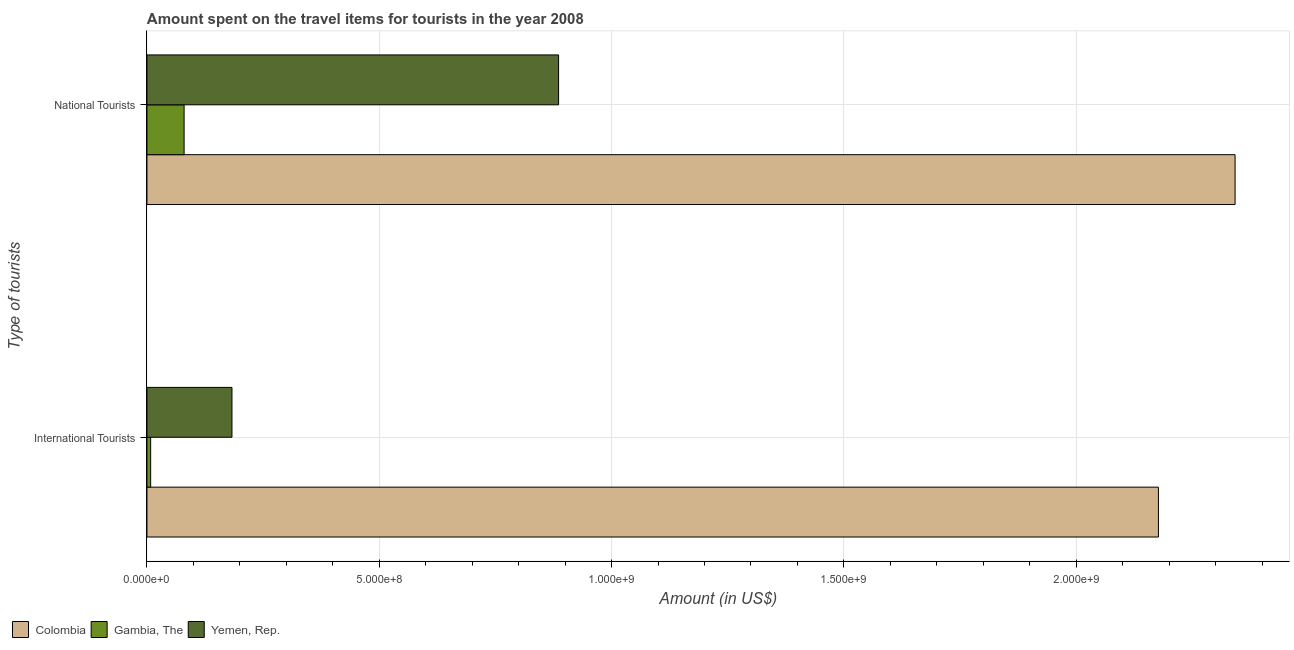How many different coloured bars are there?
Your answer should be very brief. 3. How many groups of bars are there?
Provide a succinct answer. 2. Are the number of bars per tick equal to the number of legend labels?
Keep it short and to the point. Yes. How many bars are there on the 2nd tick from the top?
Your answer should be compact. 3. How many bars are there on the 2nd tick from the bottom?
Your answer should be compact. 3. What is the label of the 1st group of bars from the top?
Offer a terse response. National Tourists. What is the amount spent on travel items of international tourists in Gambia, The?
Ensure brevity in your answer.  8.00e+06. Across all countries, what is the maximum amount spent on travel items of national tourists?
Your response must be concise. 2.34e+09. Across all countries, what is the minimum amount spent on travel items of national tourists?
Make the answer very short. 8.00e+07. In which country was the amount spent on travel items of national tourists maximum?
Keep it short and to the point. Colombia. In which country was the amount spent on travel items of national tourists minimum?
Your response must be concise. Gambia, The. What is the total amount spent on travel items of national tourists in the graph?
Offer a very short reply. 3.31e+09. What is the difference between the amount spent on travel items of national tourists in Colombia and that in Yemen, Rep.?
Your response must be concise. 1.46e+09. What is the difference between the amount spent on travel items of national tourists in Gambia, The and the amount spent on travel items of international tourists in Yemen, Rep.?
Provide a succinct answer. -1.03e+08. What is the average amount spent on travel items of international tourists per country?
Your answer should be very brief. 7.89e+08. What is the difference between the amount spent on travel items of national tourists and amount spent on travel items of international tourists in Colombia?
Your response must be concise. 1.65e+08. In how many countries, is the amount spent on travel items of national tourists greater than 2300000000 US$?
Offer a very short reply. 1. What is the ratio of the amount spent on travel items of international tourists in Colombia to that in Yemen, Rep.?
Offer a very short reply. 11.9. Are the values on the major ticks of X-axis written in scientific E-notation?
Ensure brevity in your answer.  Yes. Does the graph contain any zero values?
Provide a succinct answer. No. Where does the legend appear in the graph?
Make the answer very short. Bottom left. How are the legend labels stacked?
Your answer should be very brief. Horizontal. What is the title of the graph?
Your answer should be compact. Amount spent on the travel items for tourists in the year 2008. Does "Suriname" appear as one of the legend labels in the graph?
Make the answer very short. No. What is the label or title of the X-axis?
Your answer should be compact. Amount (in US$). What is the label or title of the Y-axis?
Provide a succinct answer. Type of tourists. What is the Amount (in US$) in Colombia in International Tourists?
Provide a succinct answer. 2.18e+09. What is the Amount (in US$) in Gambia, The in International Tourists?
Ensure brevity in your answer.  8.00e+06. What is the Amount (in US$) in Yemen, Rep. in International Tourists?
Provide a succinct answer. 1.83e+08. What is the Amount (in US$) of Colombia in National Tourists?
Provide a short and direct response. 2.34e+09. What is the Amount (in US$) of Gambia, The in National Tourists?
Provide a succinct answer. 8.00e+07. What is the Amount (in US$) of Yemen, Rep. in National Tourists?
Your answer should be compact. 8.86e+08. Across all Type of tourists, what is the maximum Amount (in US$) in Colombia?
Offer a very short reply. 2.34e+09. Across all Type of tourists, what is the maximum Amount (in US$) of Gambia, The?
Offer a very short reply. 8.00e+07. Across all Type of tourists, what is the maximum Amount (in US$) in Yemen, Rep.?
Ensure brevity in your answer.  8.86e+08. Across all Type of tourists, what is the minimum Amount (in US$) in Colombia?
Offer a terse response. 2.18e+09. Across all Type of tourists, what is the minimum Amount (in US$) in Yemen, Rep.?
Make the answer very short. 1.83e+08. What is the total Amount (in US$) in Colombia in the graph?
Make the answer very short. 4.52e+09. What is the total Amount (in US$) in Gambia, The in the graph?
Your answer should be compact. 8.80e+07. What is the total Amount (in US$) in Yemen, Rep. in the graph?
Offer a terse response. 1.07e+09. What is the difference between the Amount (in US$) of Colombia in International Tourists and that in National Tourists?
Your answer should be compact. -1.65e+08. What is the difference between the Amount (in US$) in Gambia, The in International Tourists and that in National Tourists?
Your response must be concise. -7.20e+07. What is the difference between the Amount (in US$) in Yemen, Rep. in International Tourists and that in National Tourists?
Give a very brief answer. -7.03e+08. What is the difference between the Amount (in US$) in Colombia in International Tourists and the Amount (in US$) in Gambia, The in National Tourists?
Ensure brevity in your answer.  2.10e+09. What is the difference between the Amount (in US$) of Colombia in International Tourists and the Amount (in US$) of Yemen, Rep. in National Tourists?
Your answer should be very brief. 1.29e+09. What is the difference between the Amount (in US$) of Gambia, The in International Tourists and the Amount (in US$) of Yemen, Rep. in National Tourists?
Your response must be concise. -8.78e+08. What is the average Amount (in US$) in Colombia per Type of tourists?
Give a very brief answer. 2.26e+09. What is the average Amount (in US$) in Gambia, The per Type of tourists?
Provide a succinct answer. 4.40e+07. What is the average Amount (in US$) in Yemen, Rep. per Type of tourists?
Offer a terse response. 5.34e+08. What is the difference between the Amount (in US$) of Colombia and Amount (in US$) of Gambia, The in International Tourists?
Offer a terse response. 2.17e+09. What is the difference between the Amount (in US$) of Colombia and Amount (in US$) of Yemen, Rep. in International Tourists?
Your response must be concise. 1.99e+09. What is the difference between the Amount (in US$) in Gambia, The and Amount (in US$) in Yemen, Rep. in International Tourists?
Your answer should be compact. -1.75e+08. What is the difference between the Amount (in US$) in Colombia and Amount (in US$) in Gambia, The in National Tourists?
Ensure brevity in your answer.  2.26e+09. What is the difference between the Amount (in US$) of Colombia and Amount (in US$) of Yemen, Rep. in National Tourists?
Ensure brevity in your answer.  1.46e+09. What is the difference between the Amount (in US$) in Gambia, The and Amount (in US$) in Yemen, Rep. in National Tourists?
Offer a very short reply. -8.06e+08. What is the ratio of the Amount (in US$) of Colombia in International Tourists to that in National Tourists?
Offer a very short reply. 0.93. What is the ratio of the Amount (in US$) of Gambia, The in International Tourists to that in National Tourists?
Provide a succinct answer. 0.1. What is the ratio of the Amount (in US$) of Yemen, Rep. in International Tourists to that in National Tourists?
Provide a short and direct response. 0.21. What is the difference between the highest and the second highest Amount (in US$) of Colombia?
Make the answer very short. 1.65e+08. What is the difference between the highest and the second highest Amount (in US$) in Gambia, The?
Offer a very short reply. 7.20e+07. What is the difference between the highest and the second highest Amount (in US$) in Yemen, Rep.?
Give a very brief answer. 7.03e+08. What is the difference between the highest and the lowest Amount (in US$) in Colombia?
Keep it short and to the point. 1.65e+08. What is the difference between the highest and the lowest Amount (in US$) of Gambia, The?
Your answer should be compact. 7.20e+07. What is the difference between the highest and the lowest Amount (in US$) of Yemen, Rep.?
Ensure brevity in your answer.  7.03e+08. 